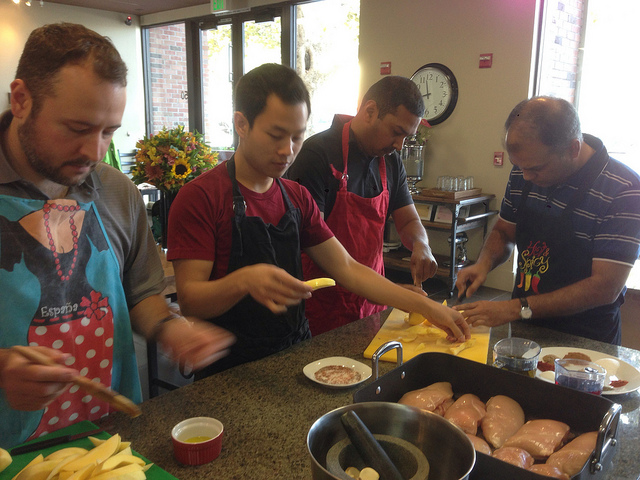What dish are they preparing? Based on the ingredients visible, such as the chicken, potatoes, and various seasonings, they might be preparing a hearty meal, possibly a baked chicken dish accompanied by seasoned potatoes. 